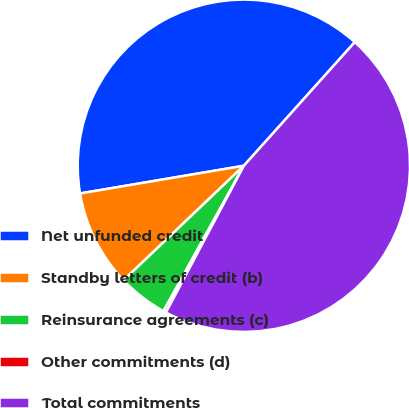Convert chart. <chart><loc_0><loc_0><loc_500><loc_500><pie_chart><fcel>Net unfunded credit<fcel>Standby letters of credit (b)<fcel>Reinsurance agreements (c)<fcel>Other commitments (d)<fcel>Total commitments<nl><fcel>39.31%<fcel>9.44%<fcel>4.85%<fcel>0.27%<fcel>46.13%<nl></chart> 